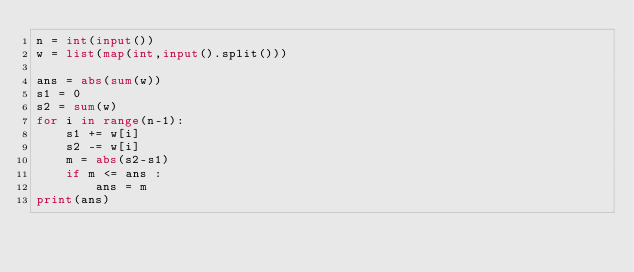Convert code to text. <code><loc_0><loc_0><loc_500><loc_500><_Python_>n = int(input())
w = list(map(int,input().split()))

ans = abs(sum(w))
s1 = 0
s2 = sum(w)
for i in range(n-1):
    s1 += w[i]
    s2 -= w[i]
    m = abs(s2-s1)
    if m <= ans :
        ans = m
print(ans)
</code> 